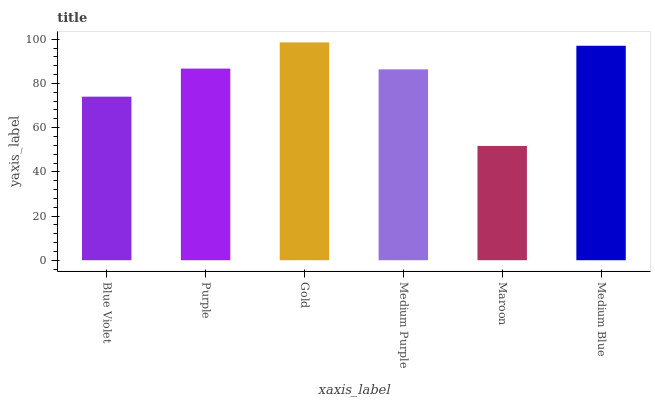Is Purple the minimum?
Answer yes or no. No. Is Purple the maximum?
Answer yes or no. No. Is Purple greater than Blue Violet?
Answer yes or no. Yes. Is Blue Violet less than Purple?
Answer yes or no. Yes. Is Blue Violet greater than Purple?
Answer yes or no. No. Is Purple less than Blue Violet?
Answer yes or no. No. Is Purple the high median?
Answer yes or no. Yes. Is Medium Purple the low median?
Answer yes or no. Yes. Is Medium Blue the high median?
Answer yes or no. No. Is Purple the low median?
Answer yes or no. No. 